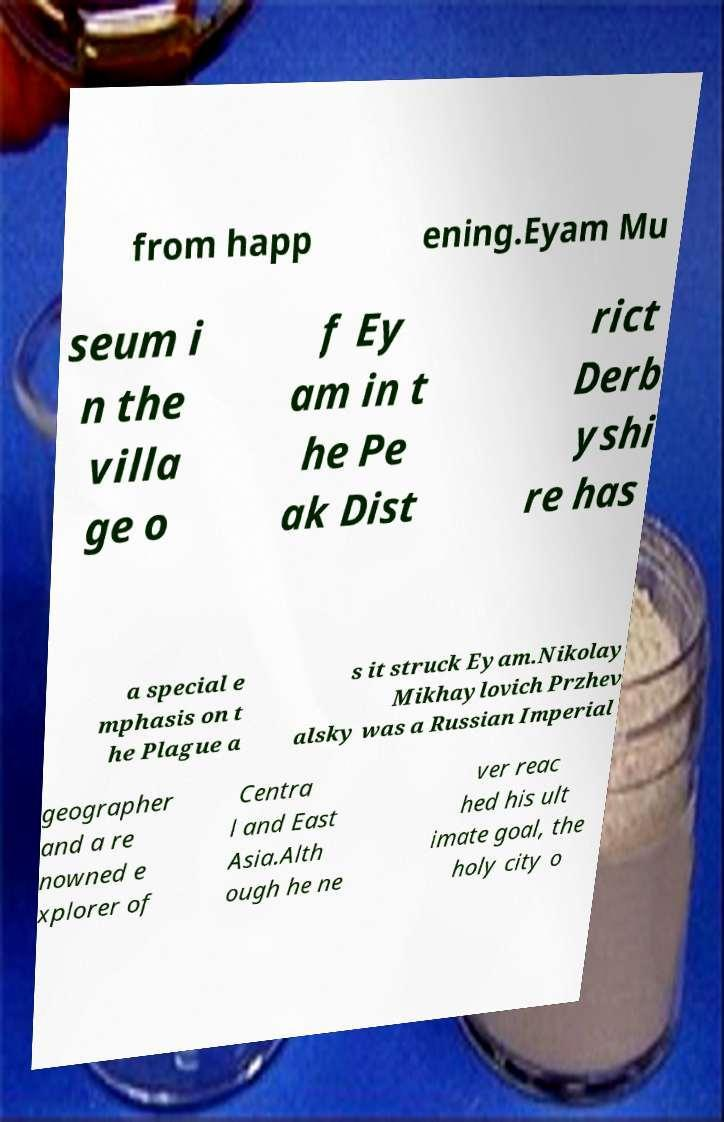For documentation purposes, I need the text within this image transcribed. Could you provide that? from happ ening.Eyam Mu seum i n the villa ge o f Ey am in t he Pe ak Dist rict Derb yshi re has a special e mphasis on t he Plague a s it struck Eyam.Nikolay Mikhaylovich Przhev alsky was a Russian Imperial geographer and a re nowned e xplorer of Centra l and East Asia.Alth ough he ne ver reac hed his ult imate goal, the holy city o 